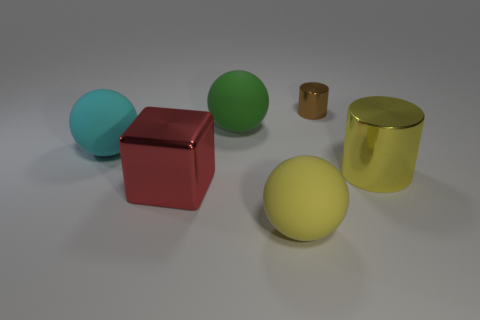Do the large matte object to the left of the red thing and the sphere that is to the right of the green rubber ball have the same color?
Provide a succinct answer. No. There is a large yellow object on the right side of the yellow rubber thing to the left of the big yellow cylinder; how many big red metallic blocks are right of it?
Keep it short and to the point. 0. How many objects are in front of the cyan ball and left of the big yellow sphere?
Your response must be concise. 1. Is the number of large yellow balls that are on the right side of the big yellow cylinder greater than the number of green balls?
Give a very brief answer. No. What number of cyan balls are the same size as the metallic block?
Provide a succinct answer. 1. What is the size of the thing that is the same color as the big cylinder?
Your answer should be very brief. Large. What number of small things are either red matte cylinders or green balls?
Provide a succinct answer. 0. What number of big red shiny objects are there?
Your response must be concise. 1. Is the number of brown objects in front of the large green matte ball the same as the number of green spheres in front of the red metallic thing?
Keep it short and to the point. Yes. Are there any large yellow metal objects behind the cyan thing?
Keep it short and to the point. No. 